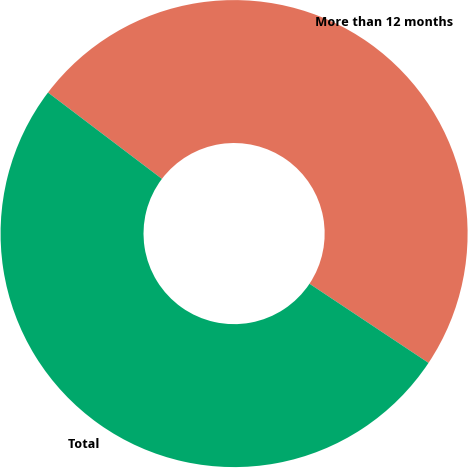Convert chart. <chart><loc_0><loc_0><loc_500><loc_500><pie_chart><fcel>More than 12 months<fcel>Total<nl><fcel>49.02%<fcel>50.98%<nl></chart> 